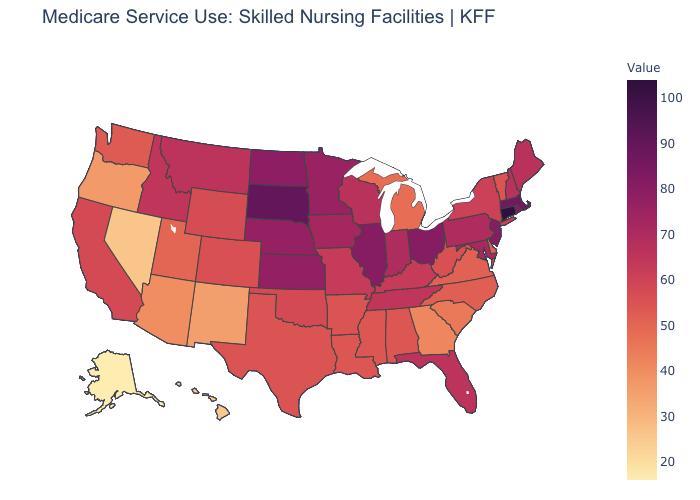Among the states that border Rhode Island , which have the highest value?
Write a very short answer. Connecticut. Does Kansas have the lowest value in the MidWest?
Be succinct. No. Does the map have missing data?
Short answer required. No. Does Washington have the lowest value in the USA?
Quick response, please. No. 